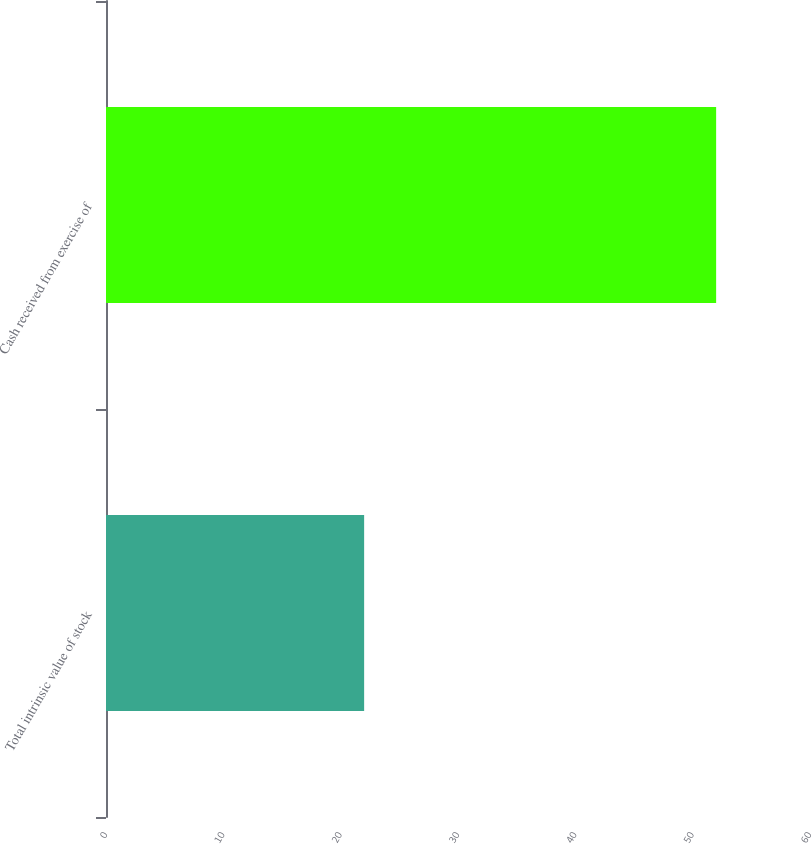<chart> <loc_0><loc_0><loc_500><loc_500><bar_chart><fcel>Total intrinsic value of stock<fcel>Cash received from exercise of<nl><fcel>22<fcel>52<nl></chart> 